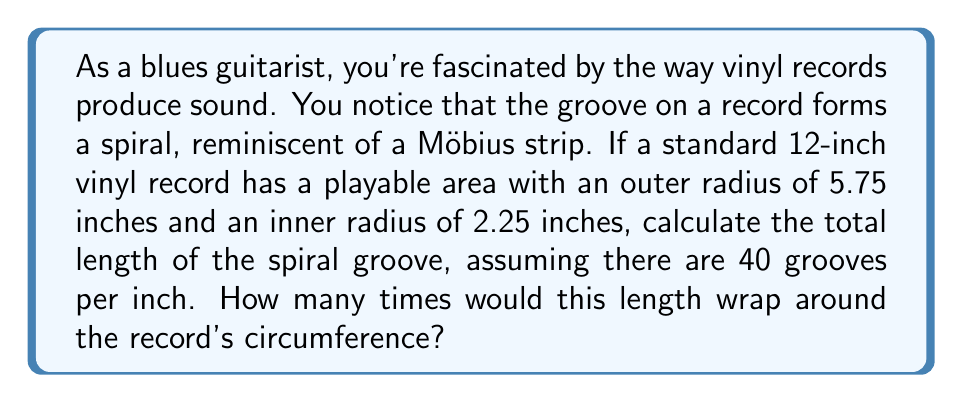Could you help me with this problem? Let's approach this step-by-step:

1) First, we need to calculate the area of the playable surface:
   $$A = \pi(r_o^2 - r_i^2)$$
   where $r_o$ is the outer radius and $r_i$ is the inner radius.
   
   $$A = \pi(5.75^2 - 2.25^2) = \pi(33.0625 - 5.0625) = 27.99\pi \approx 87.92 \text{ sq inches}$$

2) Now, if there are 40 grooves per inch, we can calculate the total length of the groove:
   $$L = 40 * 87.92 = 3516.8 \text{ inches}$$

3) To find how many times this would wrap around the record, we need to calculate the circumference of the record:
   $$C = 2\pi r = 2\pi * 6 = 12\pi \approx 37.7 \text{ inches}$$

4) Now we can divide the length of the groove by the circumference:
   $$\text{Number of wraps} = \frac{3516.8}{37.7} \approx 93.28$$

This result shows a property similar to a Möbius strip in that the groove forms a continuous path that wraps around the record multiple times, although unlike a true Möbius strip, it doesn't form a single-sided surface.
Answer: The total length of the spiral groove is approximately 3516.8 inches, and it would wrap around the record's circumference about 93 times. 